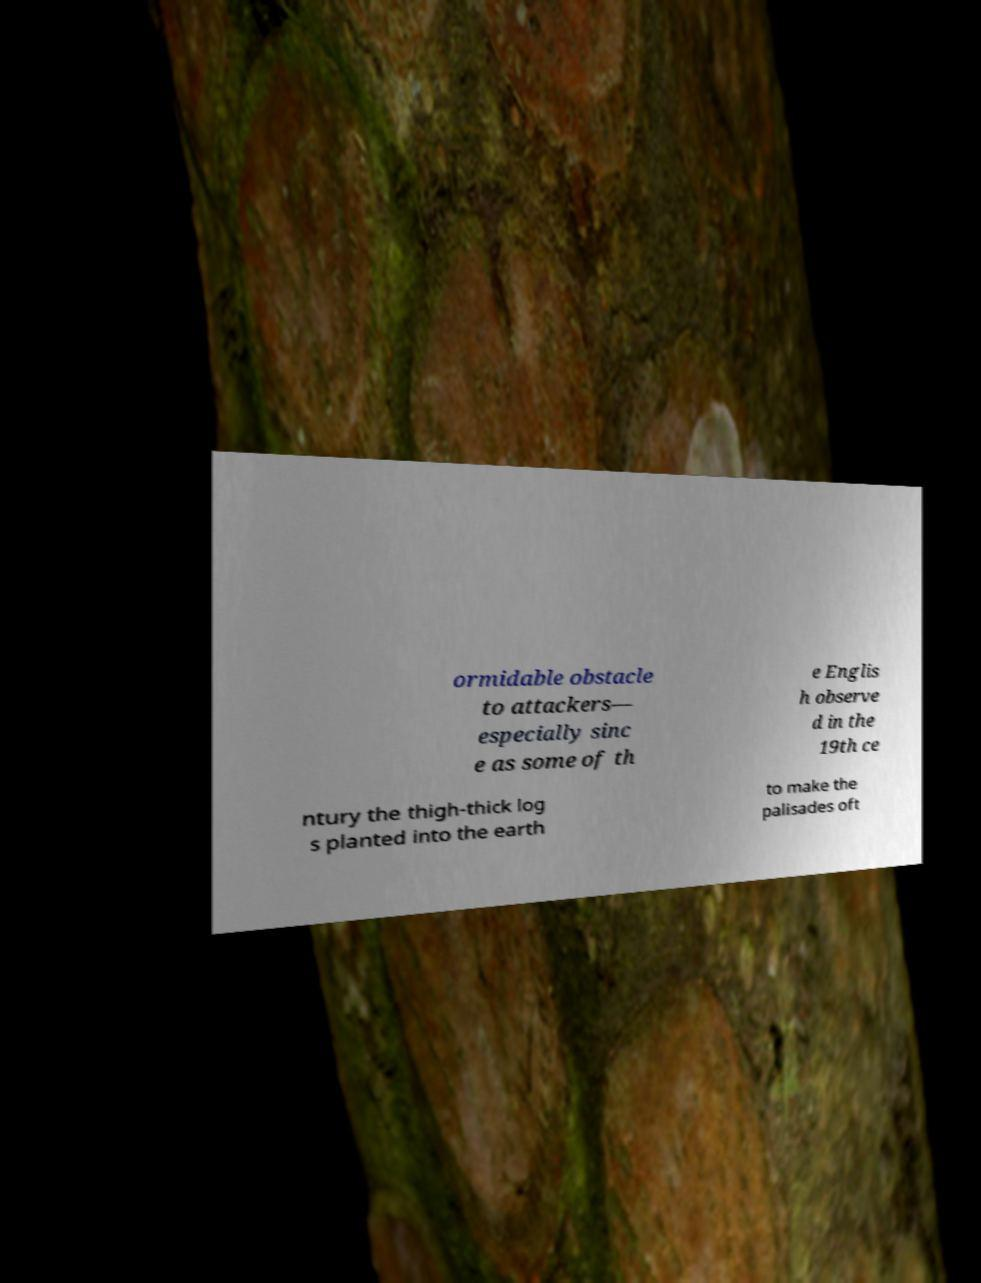Can you accurately transcribe the text from the provided image for me? ormidable obstacle to attackers— especially sinc e as some of th e Englis h observe d in the 19th ce ntury the thigh-thick log s planted into the earth to make the palisades oft 